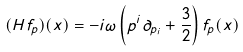Convert formula to latex. <formula><loc_0><loc_0><loc_500><loc_500>( H f _ { p } ) ( x ) = - i \omega \left ( p ^ { i } \partial _ { p _ { i } } + { \frac { 3 } { 2 } } \right ) f _ { p } ( x )</formula> 